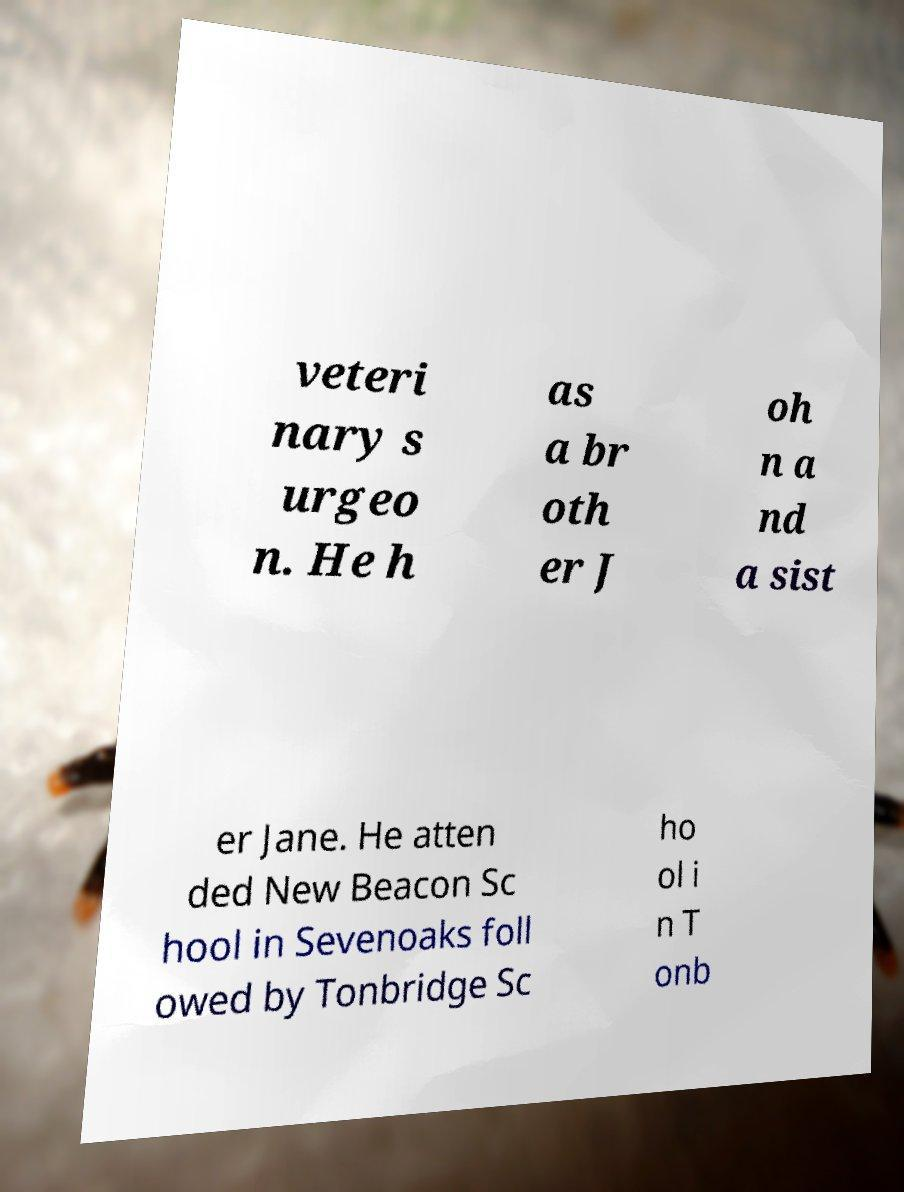Please read and relay the text visible in this image. What does it say? veteri nary s urgeo n. He h as a br oth er J oh n a nd a sist er Jane. He atten ded New Beacon Sc hool in Sevenoaks foll owed by Tonbridge Sc ho ol i n T onb 